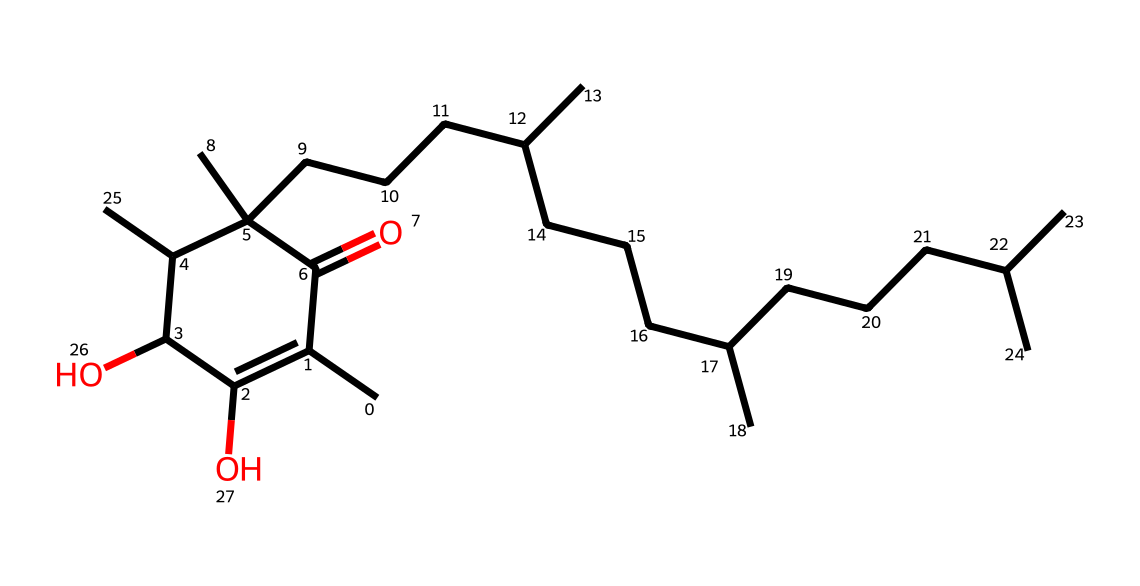What is the molecular formula of this vitamin E compound? To determine the molecular formula, we need to count the number of carbon (C), hydrogen (H), and oxygen (O) atoms in the chemical structure. From the SMILES representation, we can find that there are 35 carbons, 58 hydrogens, and 2 oxygens. Hence, the molecular formula is C35H58O2.
Answer: C35H58O2 How many double bonds are present in the vitamin E structure? Counting the double bonds means identifying the double bonds in the chemical representation. Looking at the structure, there are 2 double bonds (noted where carbon atoms are connected to other atoms or double-bonded to each other).
Answer: 2 What role do the hydroxyl groups (-OH) play in this vitamin E compound? The presence of hydroxyl groups in organic compounds typically contributes to their solubility and reactivity. In vitamin E, the hydroxyl groups provide antioxidant properties, which help protect skin health and reduce stress.
Answer: antioxidant properties Is vitamin E a water-soluble or fat-soluble vitamin? Vitamin E is recognized as a fat-soluble vitamin, which means it dissolves in fats and is typically stored in body tissues, rather than in water. This is due to its long carbon chains, making it hydrophobic.
Answer: fat-soluble What functional groups are present in this vitamin E structure? In the given chemical, there are hydroxyl (-OH) groups and carbonyl (C=O) groups present, which are both significant functional groups that contribute to its properties and activities.
Answer: hydroxyl and carbonyl 